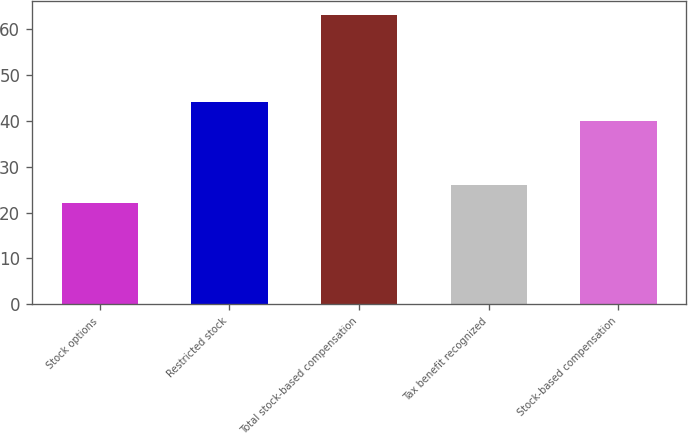Convert chart to OTSL. <chart><loc_0><loc_0><loc_500><loc_500><bar_chart><fcel>Stock options<fcel>Restricted stock<fcel>Total stock-based compensation<fcel>Tax benefit recognized<fcel>Stock-based compensation<nl><fcel>22<fcel>44.1<fcel>63<fcel>26.1<fcel>40<nl></chart> 